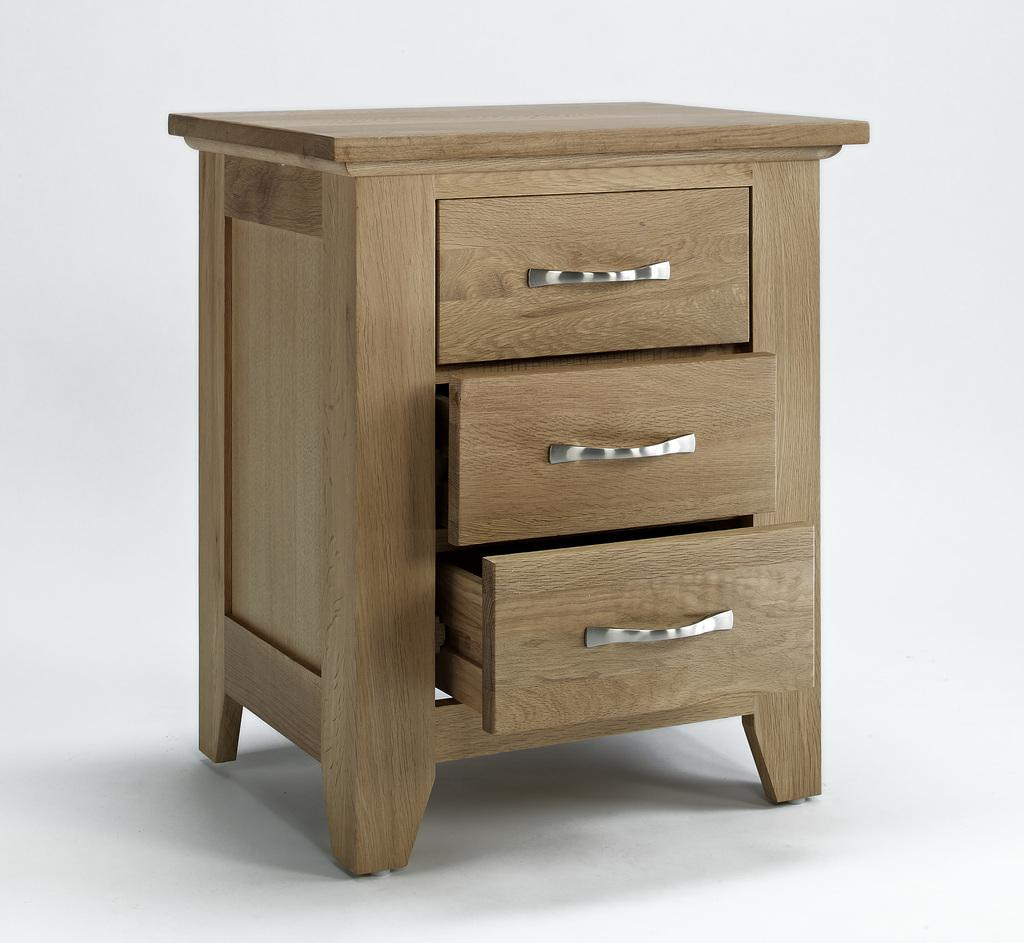What type of furniture is in the center of the image? There is a wooden cupboard in the center of the image. Can you describe the position of the wooden cupboard in the image? The wooden cupboard is in the center of the image. What type of linen can be seen draped over the hill in the image? There is no linen or hill present in the image; it only features a wooden cupboard. 